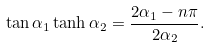Convert formula to latex. <formula><loc_0><loc_0><loc_500><loc_500>\tan \alpha _ { 1 } \tanh \alpha _ { 2 } = \frac { 2 \alpha _ { 1 } - n \pi } { 2 \alpha _ { 2 } } .</formula> 